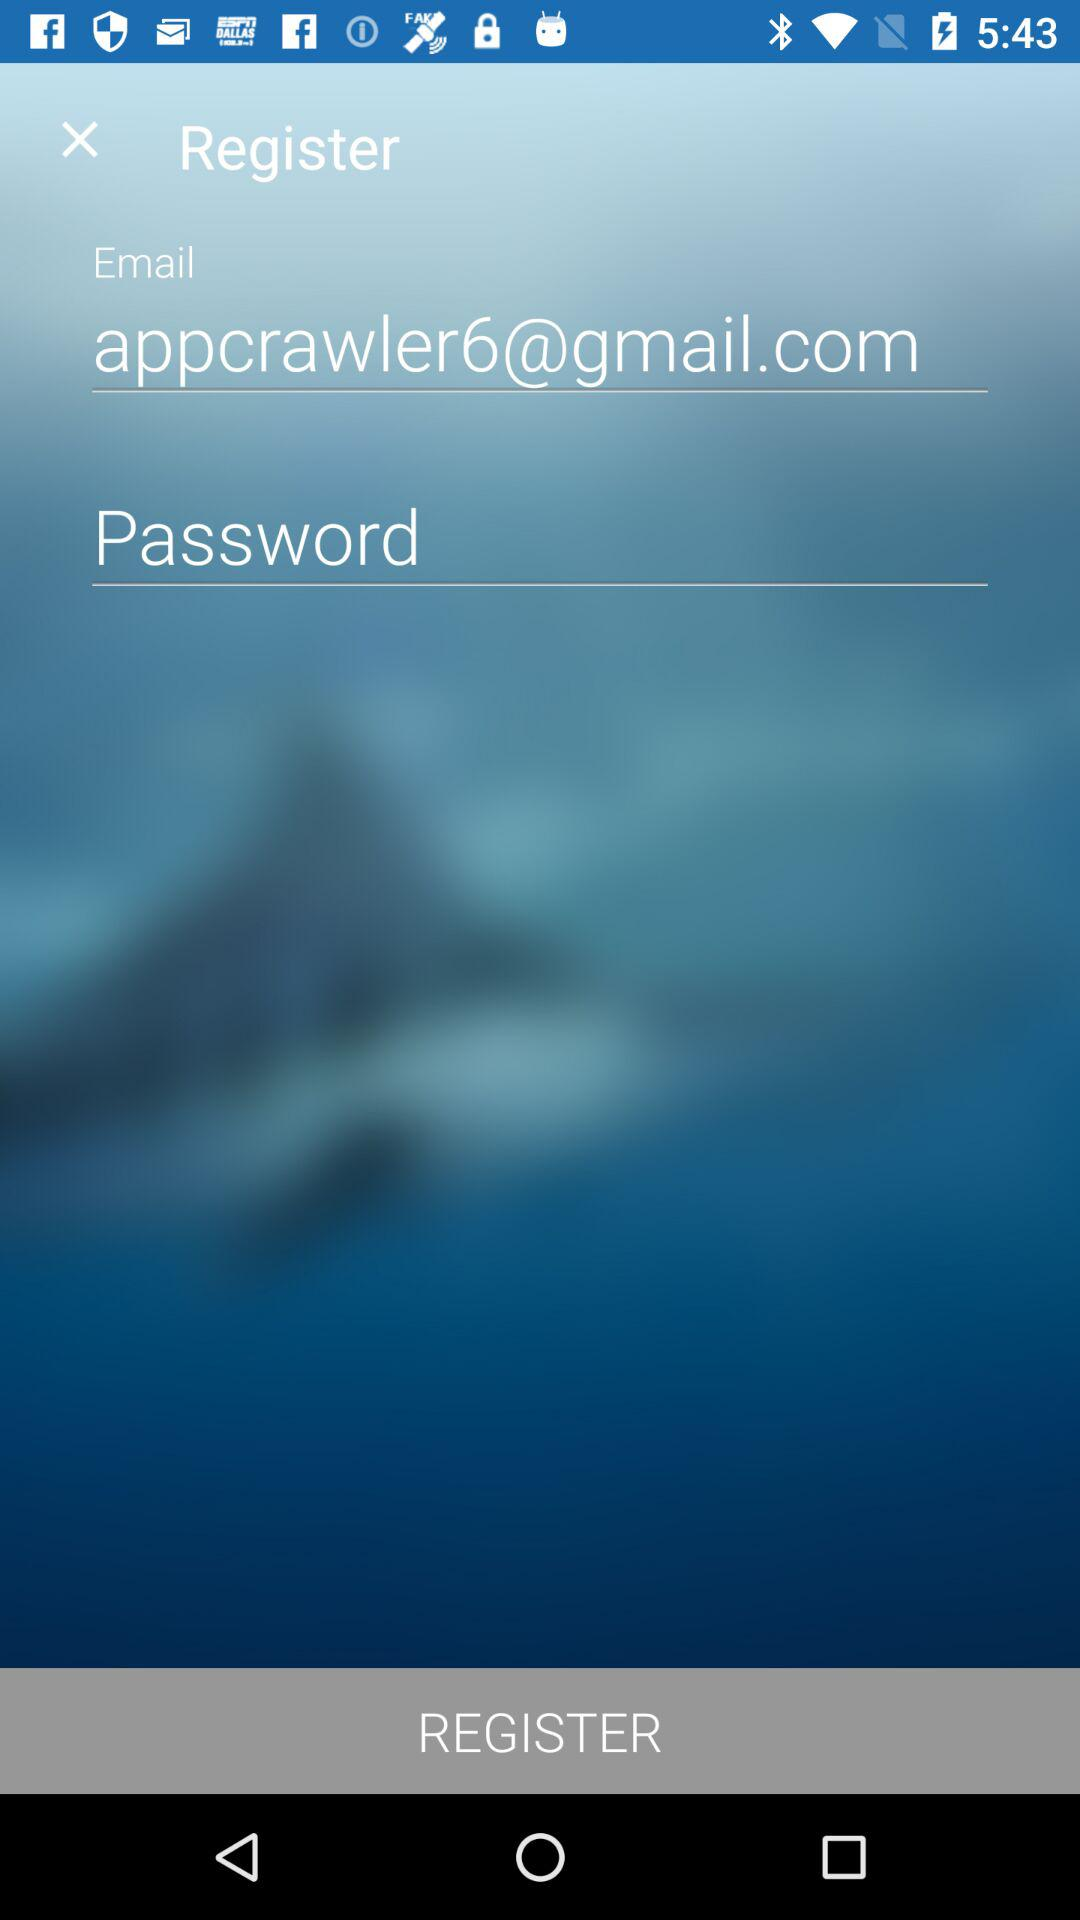What is the email address? The email address is appcrawler6@gmail.com. 